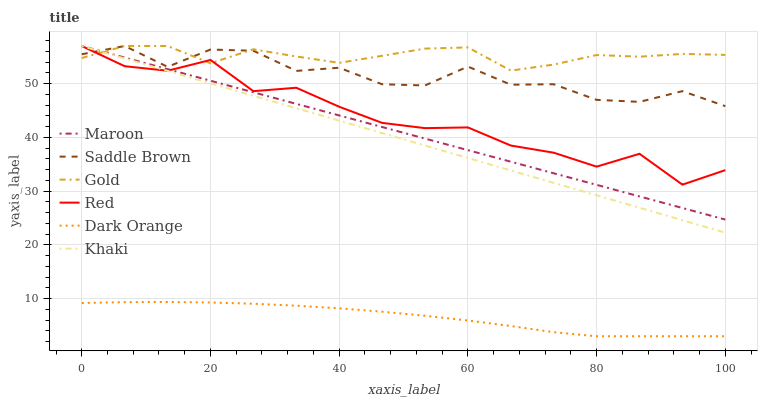Does Khaki have the minimum area under the curve?
Answer yes or no. No. Does Khaki have the maximum area under the curve?
Answer yes or no. No. Is Khaki the smoothest?
Answer yes or no. No. Is Khaki the roughest?
Answer yes or no. No. Does Khaki have the lowest value?
Answer yes or no. No. Is Dark Orange less than Maroon?
Answer yes or no. Yes. Is Red greater than Dark Orange?
Answer yes or no. Yes. Does Dark Orange intersect Maroon?
Answer yes or no. No. 